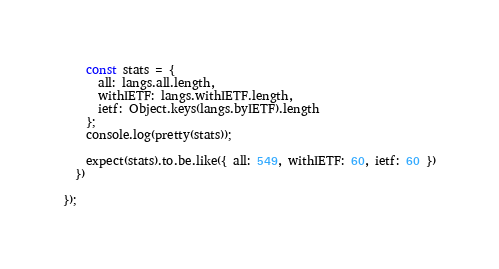<code> <loc_0><loc_0><loc_500><loc_500><_JavaScript_>    const stats = {
      all: langs.all.length,
      withIETF: langs.withIETF.length,
      ietf: Object.keys(langs.byIETF).length
    };
    console.log(pretty(stats));

    expect(stats).to.be.like({ all: 549, withIETF: 60, ietf: 60 })
  })

});
</code> 